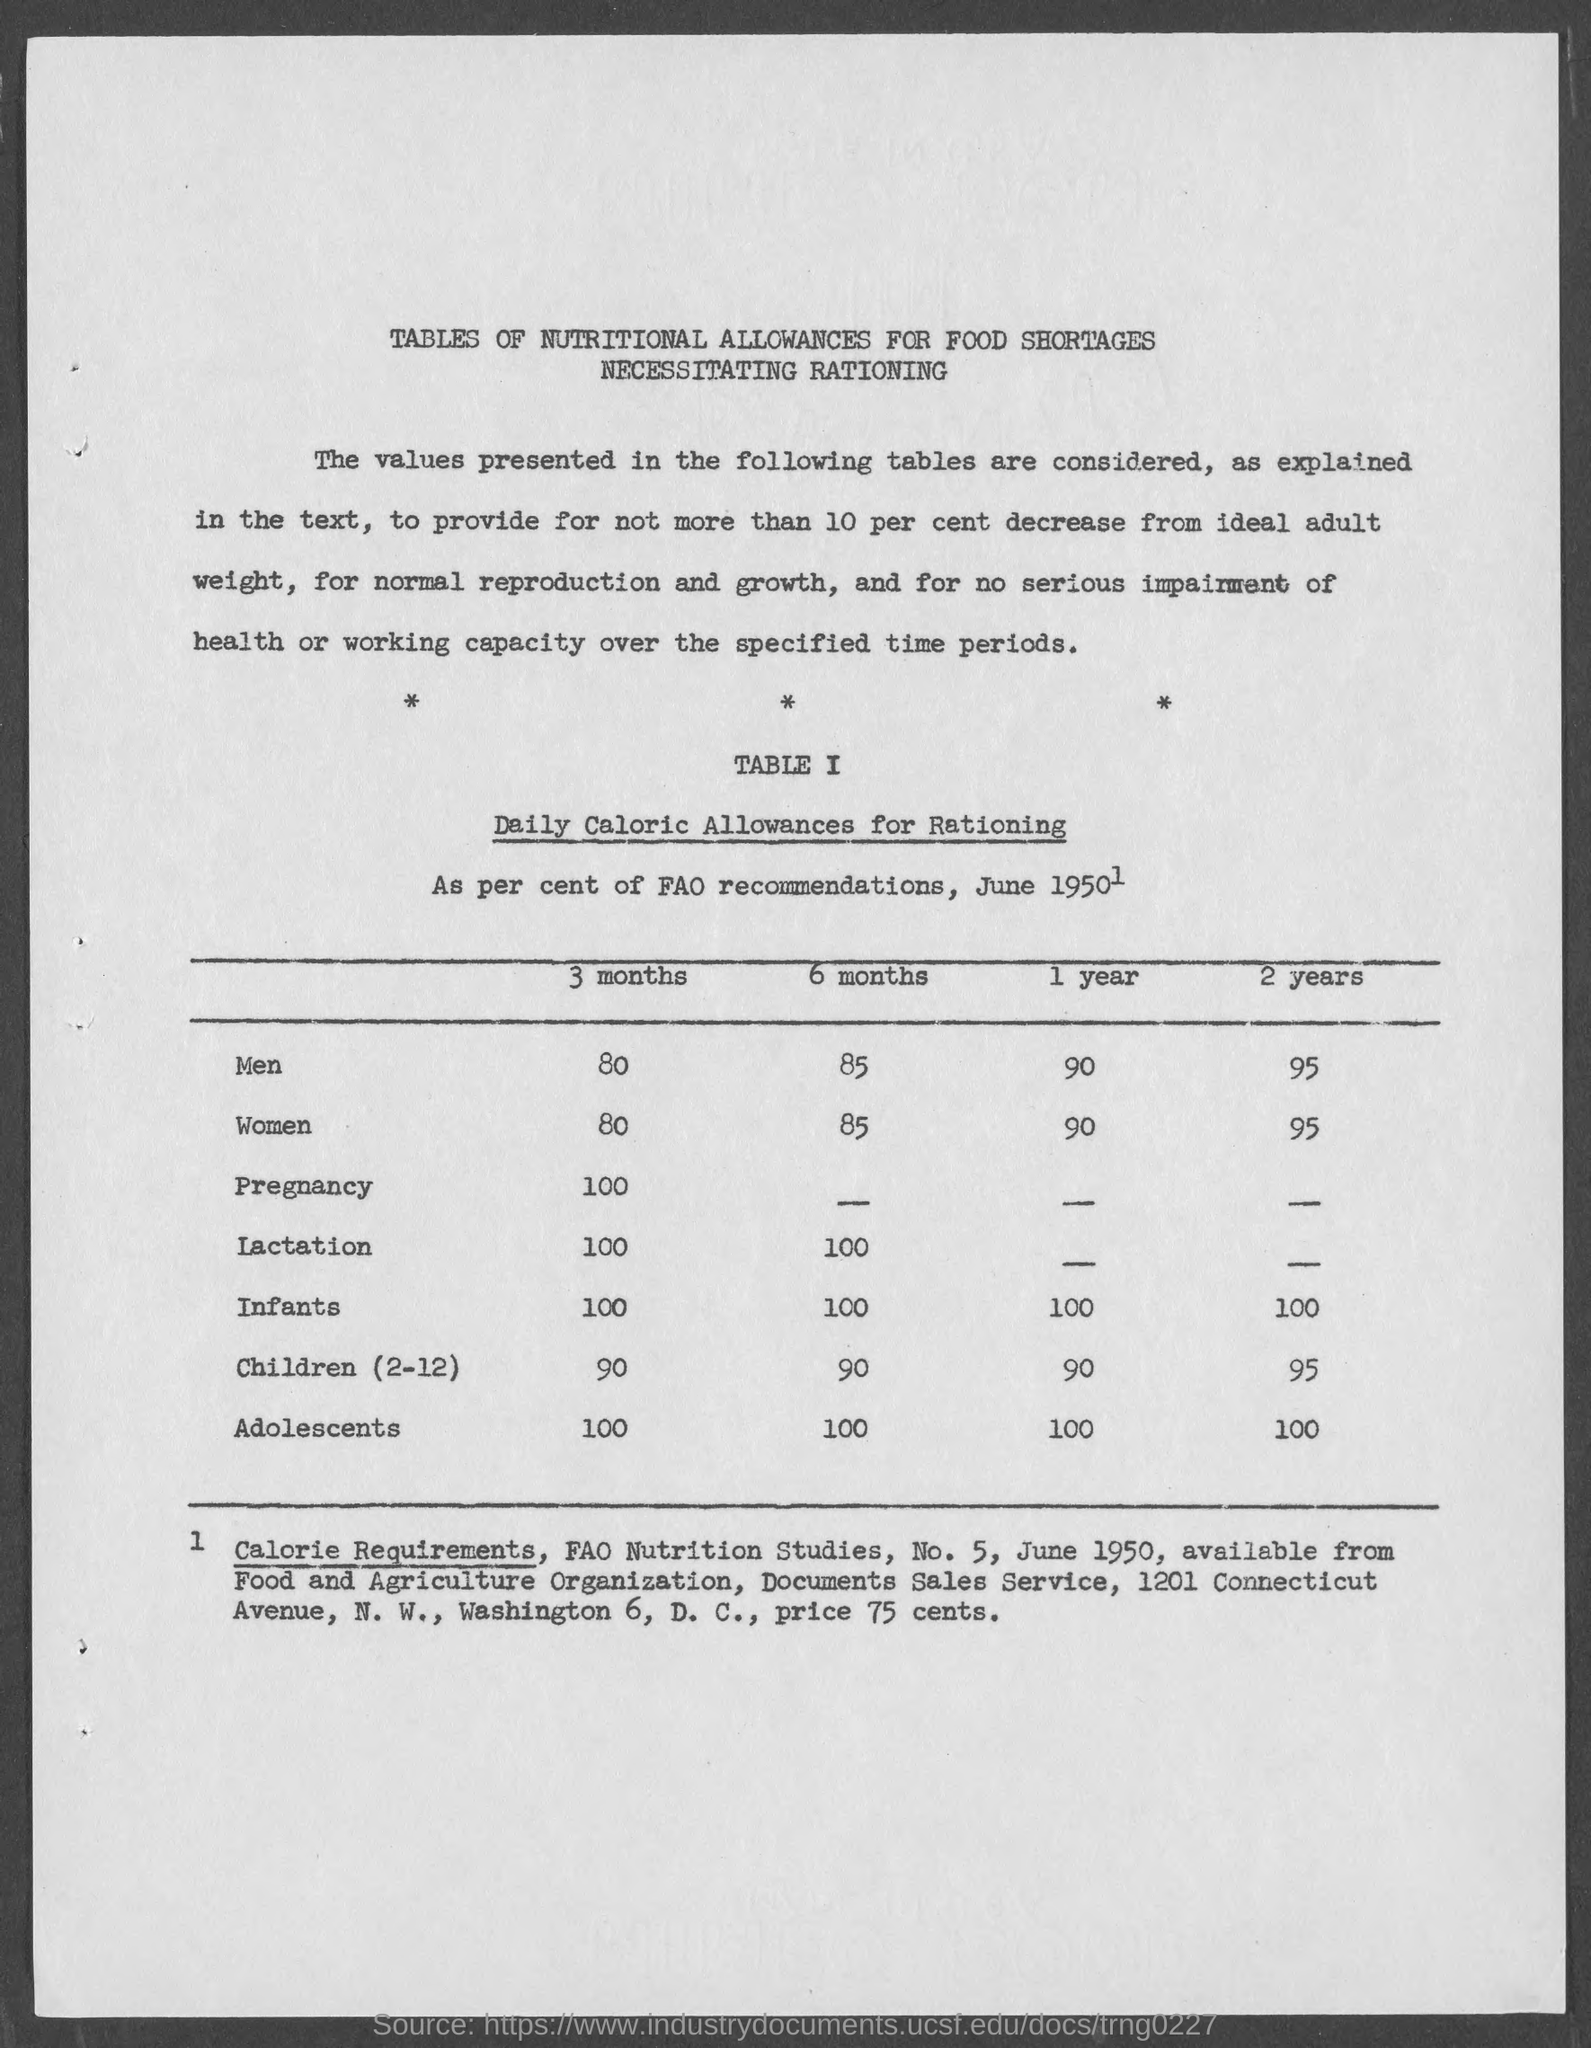What is the Daily calorie allowances for rationing for men for 3 months?
Keep it short and to the point. 80. What is the Daily calorie allowances for rationing for men for 6 months?
Offer a terse response. 85. What is the Daily calorie allowances for rationing for men for 1 year?
Offer a very short reply. 90. What is the Daily calorie allowances for rationing for men for 2 years?
Your response must be concise. 95. What is the Daily calorie allowances for rationing for Women for 3 months?
Offer a very short reply. 80. What is the Daily calorie allowances for rationing for Women for 6 months?
Make the answer very short. 85. What is the Daily calorie allowances for rationing for Women for 1 year?
Offer a very short reply. 90. What is the Daily calorie allowances for rationing for Women for 2 years?
Your response must be concise. 95. What is the Daily calorie allowances for rationing for pregnancy for 3 months?
Offer a very short reply. 100. What is the Daily calorie allowances for rationing for Lactation for 3 months?
Provide a succinct answer. 100. 